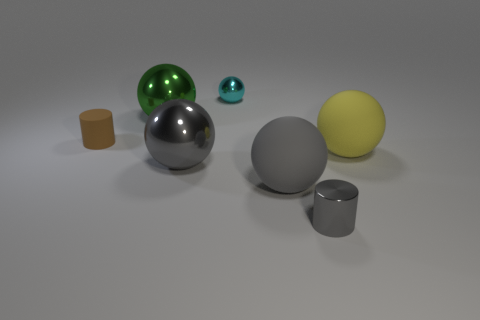Subtract 3 spheres. How many spheres are left? 2 Subtract all yellow balls. How many balls are left? 4 Subtract all gray matte balls. How many balls are left? 4 Add 1 large cylinders. How many objects exist? 8 Subtract all red spheres. Subtract all blue cubes. How many spheres are left? 5 Subtract all balls. How many objects are left? 2 Add 4 tiny cyan spheres. How many tiny cyan spheres are left? 5 Add 4 big matte balls. How many big matte balls exist? 6 Subtract 0 purple cylinders. How many objects are left? 7 Subtract all red things. Subtract all big green objects. How many objects are left? 6 